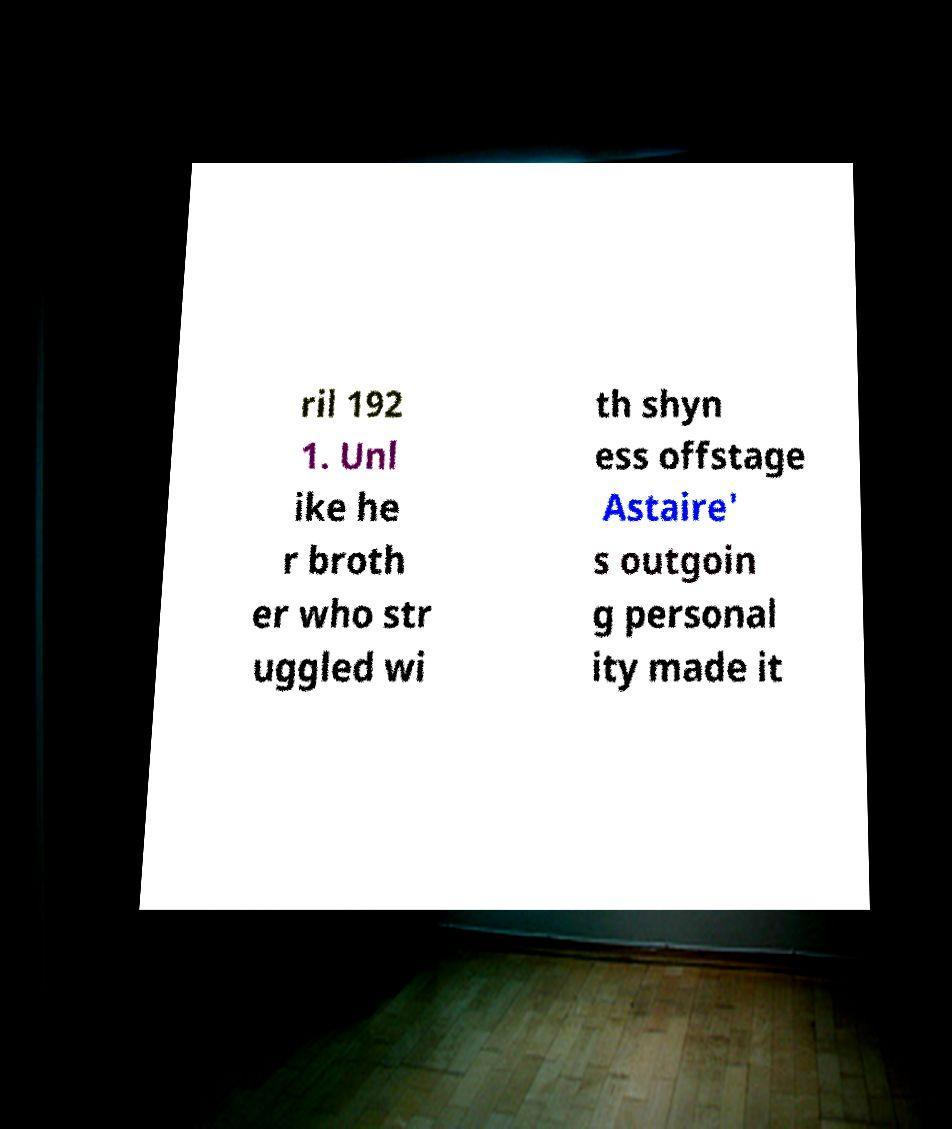Can you read and provide the text displayed in the image?This photo seems to have some interesting text. Can you extract and type it out for me? ril 192 1. Unl ike he r broth er who str uggled wi th shyn ess offstage Astaire' s outgoin g personal ity made it 